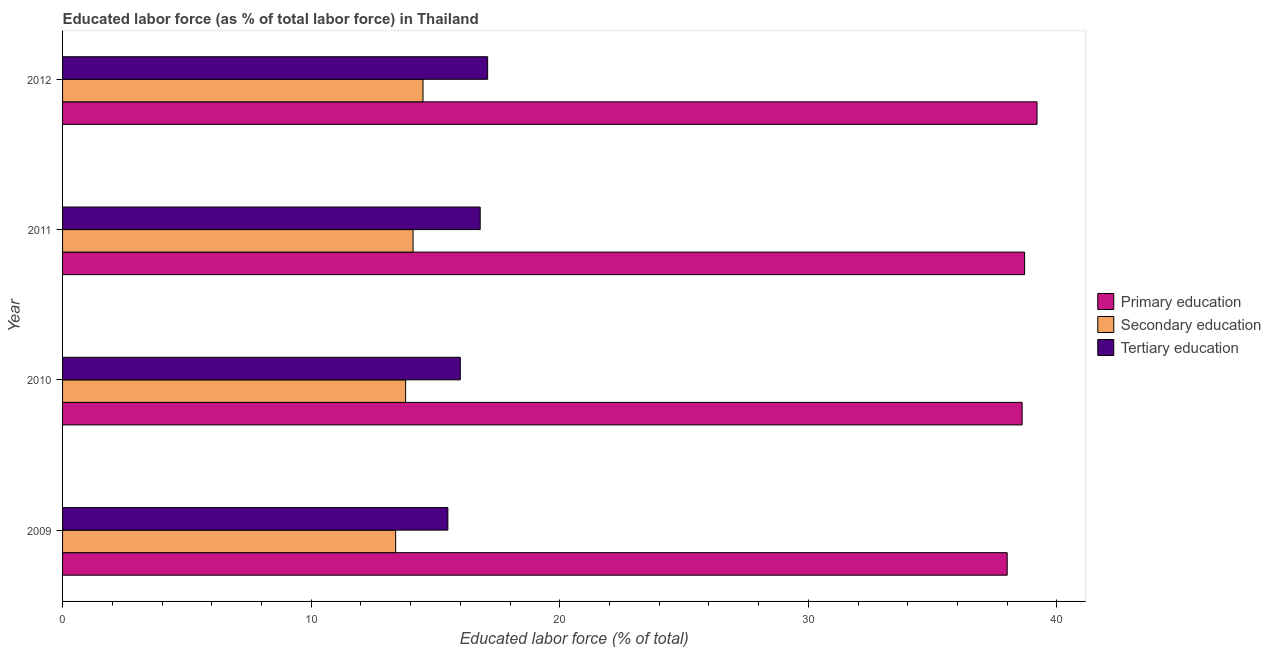Are the number of bars per tick equal to the number of legend labels?
Give a very brief answer. Yes. Are the number of bars on each tick of the Y-axis equal?
Make the answer very short. Yes. What is the percentage of labor force who received secondary education in 2009?
Provide a short and direct response. 13.4. Across all years, what is the maximum percentage of labor force who received primary education?
Make the answer very short. 39.2. Across all years, what is the minimum percentage of labor force who received secondary education?
Offer a very short reply. 13.4. In which year was the percentage of labor force who received primary education maximum?
Provide a short and direct response. 2012. What is the total percentage of labor force who received primary education in the graph?
Keep it short and to the point. 154.5. What is the difference between the percentage of labor force who received primary education in 2009 and that in 2011?
Your answer should be very brief. -0.7. What is the difference between the percentage of labor force who received primary education in 2011 and the percentage of labor force who received tertiary education in 2009?
Your answer should be compact. 23.2. What is the average percentage of labor force who received primary education per year?
Make the answer very short. 38.62. In the year 2012, what is the difference between the percentage of labor force who received tertiary education and percentage of labor force who received primary education?
Provide a short and direct response. -22.1. What is the ratio of the percentage of labor force who received primary education in 2009 to that in 2010?
Your answer should be compact. 0.98. Is the difference between the percentage of labor force who received primary education in 2009 and 2011 greater than the difference between the percentage of labor force who received tertiary education in 2009 and 2011?
Your answer should be very brief. Yes. What does the 2nd bar from the top in 2011 represents?
Your response must be concise. Secondary education. What does the 2nd bar from the bottom in 2011 represents?
Your response must be concise. Secondary education. How many bars are there?
Your answer should be very brief. 12. Does the graph contain any zero values?
Make the answer very short. No. Does the graph contain grids?
Provide a succinct answer. No. How many legend labels are there?
Make the answer very short. 3. How are the legend labels stacked?
Your response must be concise. Vertical. What is the title of the graph?
Offer a terse response. Educated labor force (as % of total labor force) in Thailand. What is the label or title of the X-axis?
Your answer should be compact. Educated labor force (% of total). What is the label or title of the Y-axis?
Make the answer very short. Year. What is the Educated labor force (% of total) of Secondary education in 2009?
Provide a succinct answer. 13.4. What is the Educated labor force (% of total) of Primary education in 2010?
Your answer should be compact. 38.6. What is the Educated labor force (% of total) of Secondary education in 2010?
Ensure brevity in your answer.  13.8. What is the Educated labor force (% of total) of Primary education in 2011?
Provide a short and direct response. 38.7. What is the Educated labor force (% of total) in Secondary education in 2011?
Your answer should be very brief. 14.1. What is the Educated labor force (% of total) in Tertiary education in 2011?
Provide a short and direct response. 16.8. What is the Educated labor force (% of total) of Primary education in 2012?
Make the answer very short. 39.2. What is the Educated labor force (% of total) of Secondary education in 2012?
Provide a short and direct response. 14.5. What is the Educated labor force (% of total) in Tertiary education in 2012?
Offer a terse response. 17.1. Across all years, what is the maximum Educated labor force (% of total) in Primary education?
Make the answer very short. 39.2. Across all years, what is the maximum Educated labor force (% of total) in Tertiary education?
Make the answer very short. 17.1. Across all years, what is the minimum Educated labor force (% of total) in Primary education?
Ensure brevity in your answer.  38. Across all years, what is the minimum Educated labor force (% of total) in Secondary education?
Provide a succinct answer. 13.4. Across all years, what is the minimum Educated labor force (% of total) in Tertiary education?
Offer a terse response. 15.5. What is the total Educated labor force (% of total) of Primary education in the graph?
Provide a succinct answer. 154.5. What is the total Educated labor force (% of total) of Secondary education in the graph?
Make the answer very short. 55.8. What is the total Educated labor force (% of total) in Tertiary education in the graph?
Provide a short and direct response. 65.4. What is the difference between the Educated labor force (% of total) in Primary education in 2009 and that in 2010?
Keep it short and to the point. -0.6. What is the difference between the Educated labor force (% of total) of Tertiary education in 2009 and that in 2010?
Offer a terse response. -0.5. What is the difference between the Educated labor force (% of total) of Primary education in 2009 and that in 2011?
Your answer should be very brief. -0.7. What is the difference between the Educated labor force (% of total) in Secondary education in 2009 and that in 2011?
Provide a short and direct response. -0.7. What is the difference between the Educated labor force (% of total) in Tertiary education in 2009 and that in 2011?
Provide a succinct answer. -1.3. What is the difference between the Educated labor force (% of total) in Primary education in 2009 and that in 2012?
Offer a terse response. -1.2. What is the difference between the Educated labor force (% of total) in Secondary education in 2009 and that in 2012?
Keep it short and to the point. -1.1. What is the difference between the Educated labor force (% of total) in Tertiary education in 2009 and that in 2012?
Give a very brief answer. -1.6. What is the difference between the Educated labor force (% of total) in Primary education in 2010 and that in 2011?
Offer a very short reply. -0.1. What is the difference between the Educated labor force (% of total) of Secondary education in 2010 and that in 2011?
Ensure brevity in your answer.  -0.3. What is the difference between the Educated labor force (% of total) in Tertiary education in 2010 and that in 2011?
Keep it short and to the point. -0.8. What is the difference between the Educated labor force (% of total) of Secondary education in 2011 and that in 2012?
Make the answer very short. -0.4. What is the difference between the Educated labor force (% of total) of Tertiary education in 2011 and that in 2012?
Offer a terse response. -0.3. What is the difference between the Educated labor force (% of total) of Primary education in 2009 and the Educated labor force (% of total) of Secondary education in 2010?
Provide a succinct answer. 24.2. What is the difference between the Educated labor force (% of total) of Primary education in 2009 and the Educated labor force (% of total) of Tertiary education in 2010?
Ensure brevity in your answer.  22. What is the difference between the Educated labor force (% of total) of Secondary education in 2009 and the Educated labor force (% of total) of Tertiary education in 2010?
Your answer should be compact. -2.6. What is the difference between the Educated labor force (% of total) in Primary education in 2009 and the Educated labor force (% of total) in Secondary education in 2011?
Provide a short and direct response. 23.9. What is the difference between the Educated labor force (% of total) in Primary education in 2009 and the Educated labor force (% of total) in Tertiary education in 2011?
Make the answer very short. 21.2. What is the difference between the Educated labor force (% of total) of Primary education in 2009 and the Educated labor force (% of total) of Tertiary education in 2012?
Offer a terse response. 20.9. What is the difference between the Educated labor force (% of total) in Primary education in 2010 and the Educated labor force (% of total) in Tertiary education in 2011?
Your answer should be very brief. 21.8. What is the difference between the Educated labor force (% of total) of Secondary education in 2010 and the Educated labor force (% of total) of Tertiary education in 2011?
Keep it short and to the point. -3. What is the difference between the Educated labor force (% of total) of Primary education in 2010 and the Educated labor force (% of total) of Secondary education in 2012?
Offer a terse response. 24.1. What is the difference between the Educated labor force (% of total) of Primary education in 2010 and the Educated labor force (% of total) of Tertiary education in 2012?
Offer a very short reply. 21.5. What is the difference between the Educated labor force (% of total) of Primary education in 2011 and the Educated labor force (% of total) of Secondary education in 2012?
Your response must be concise. 24.2. What is the difference between the Educated labor force (% of total) of Primary education in 2011 and the Educated labor force (% of total) of Tertiary education in 2012?
Ensure brevity in your answer.  21.6. What is the average Educated labor force (% of total) in Primary education per year?
Provide a short and direct response. 38.62. What is the average Educated labor force (% of total) of Secondary education per year?
Your answer should be very brief. 13.95. What is the average Educated labor force (% of total) in Tertiary education per year?
Make the answer very short. 16.35. In the year 2009, what is the difference between the Educated labor force (% of total) of Primary education and Educated labor force (% of total) of Secondary education?
Provide a short and direct response. 24.6. In the year 2010, what is the difference between the Educated labor force (% of total) of Primary education and Educated labor force (% of total) of Secondary education?
Offer a very short reply. 24.8. In the year 2010, what is the difference between the Educated labor force (% of total) in Primary education and Educated labor force (% of total) in Tertiary education?
Offer a very short reply. 22.6. In the year 2011, what is the difference between the Educated labor force (% of total) of Primary education and Educated labor force (% of total) of Secondary education?
Your response must be concise. 24.6. In the year 2011, what is the difference between the Educated labor force (% of total) in Primary education and Educated labor force (% of total) in Tertiary education?
Offer a terse response. 21.9. In the year 2012, what is the difference between the Educated labor force (% of total) in Primary education and Educated labor force (% of total) in Secondary education?
Your response must be concise. 24.7. In the year 2012, what is the difference between the Educated labor force (% of total) of Primary education and Educated labor force (% of total) of Tertiary education?
Keep it short and to the point. 22.1. In the year 2012, what is the difference between the Educated labor force (% of total) of Secondary education and Educated labor force (% of total) of Tertiary education?
Your answer should be compact. -2.6. What is the ratio of the Educated labor force (% of total) of Primary education in 2009 to that in 2010?
Provide a short and direct response. 0.98. What is the ratio of the Educated labor force (% of total) of Tertiary education in 2009 to that in 2010?
Offer a terse response. 0.97. What is the ratio of the Educated labor force (% of total) of Primary education in 2009 to that in 2011?
Offer a very short reply. 0.98. What is the ratio of the Educated labor force (% of total) in Secondary education in 2009 to that in 2011?
Offer a very short reply. 0.95. What is the ratio of the Educated labor force (% of total) in Tertiary education in 2009 to that in 2011?
Ensure brevity in your answer.  0.92. What is the ratio of the Educated labor force (% of total) in Primary education in 2009 to that in 2012?
Your answer should be very brief. 0.97. What is the ratio of the Educated labor force (% of total) of Secondary education in 2009 to that in 2012?
Provide a short and direct response. 0.92. What is the ratio of the Educated labor force (% of total) of Tertiary education in 2009 to that in 2012?
Your response must be concise. 0.91. What is the ratio of the Educated labor force (% of total) of Secondary education in 2010 to that in 2011?
Provide a succinct answer. 0.98. What is the ratio of the Educated labor force (% of total) of Tertiary education in 2010 to that in 2011?
Keep it short and to the point. 0.95. What is the ratio of the Educated labor force (% of total) of Primary education in 2010 to that in 2012?
Your response must be concise. 0.98. What is the ratio of the Educated labor force (% of total) in Secondary education in 2010 to that in 2012?
Offer a very short reply. 0.95. What is the ratio of the Educated labor force (% of total) in Tertiary education in 2010 to that in 2012?
Your answer should be very brief. 0.94. What is the ratio of the Educated labor force (% of total) of Primary education in 2011 to that in 2012?
Provide a succinct answer. 0.99. What is the ratio of the Educated labor force (% of total) in Secondary education in 2011 to that in 2012?
Offer a very short reply. 0.97. What is the ratio of the Educated labor force (% of total) of Tertiary education in 2011 to that in 2012?
Offer a terse response. 0.98. What is the difference between the highest and the second highest Educated labor force (% of total) in Secondary education?
Offer a terse response. 0.4. What is the difference between the highest and the lowest Educated labor force (% of total) of Primary education?
Offer a very short reply. 1.2. What is the difference between the highest and the lowest Educated labor force (% of total) of Secondary education?
Provide a short and direct response. 1.1. 